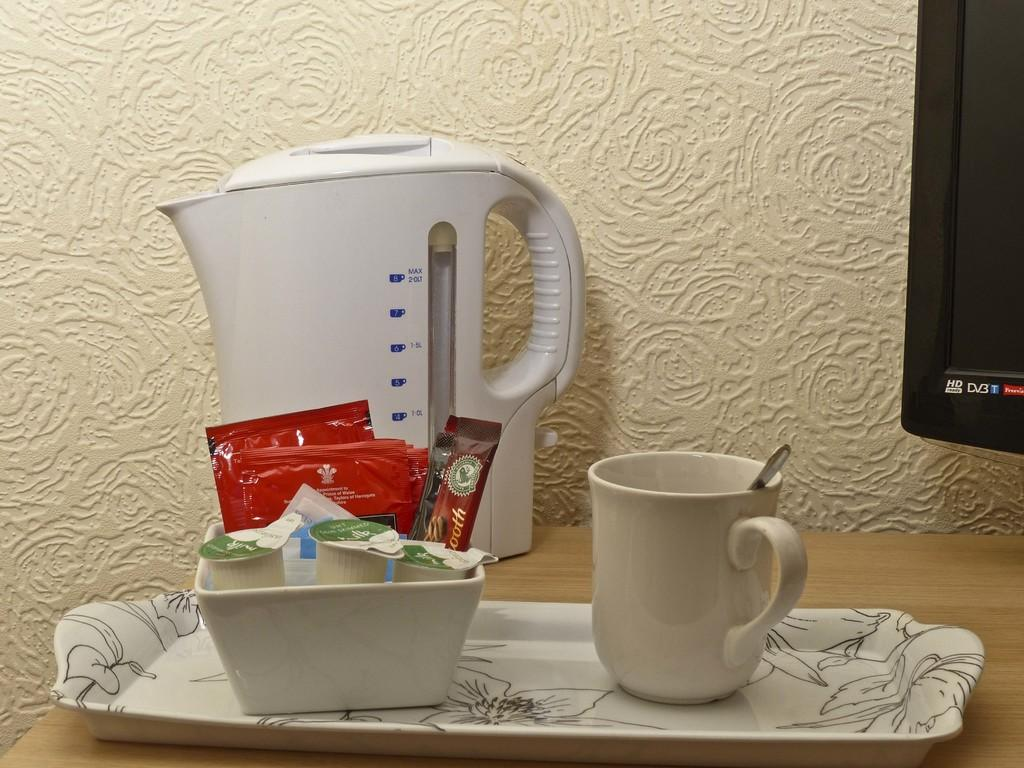<image>
Describe the image concisely. a large container that has the word max on it 